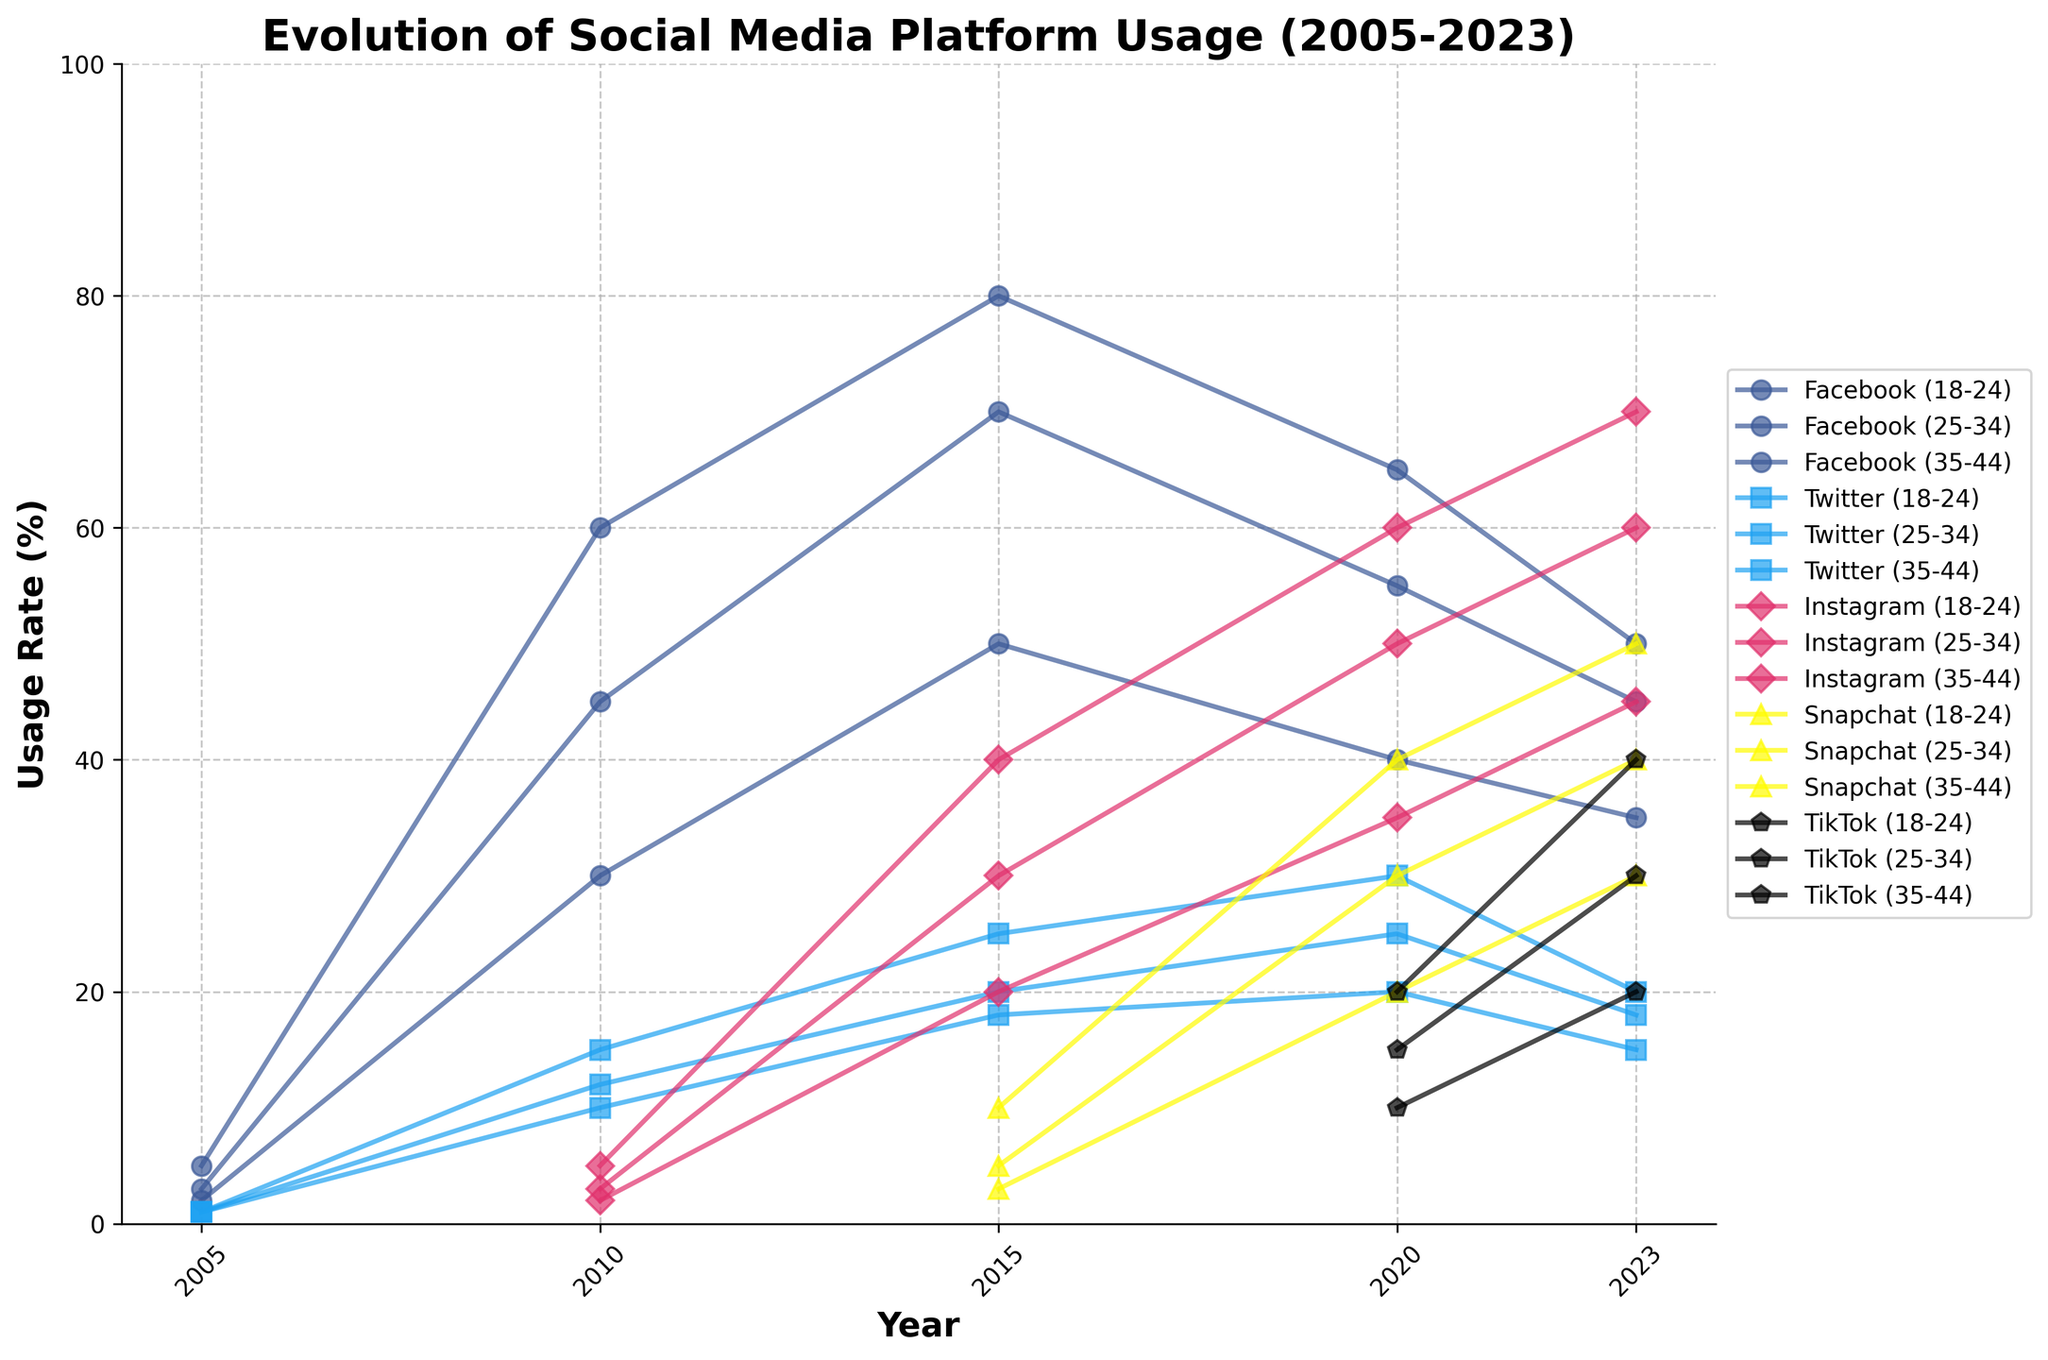What's the title of the figure? The title of the figure is given at the top of the plot.
Answer: Evolution of Social Media Platform Usage (2005-2023) What is the usage rate of Facebook for the 18-24 age group in 2015? Locate the 18-24 age group data points for the year 2015 on the plot, and look at the value on the y-axis for Facebook.
Answer: 80% Which social media platform had the highest usage rate among the 18-24 age group in 2023? Look at all the data points for the 18-24 age group in 2023 and identify the highest point among all platforms.
Answer: Instagram Compare the usage rate of TikTok for the 18-24 age group and the 35-44 age group in 2023. Locate the data points for TikTok in 2023 on the plot for both the 18-24 and 35-44 age groups and compare their values.
Answer: 40% (18-24) and 20% (35-44) How did the usage rate of Snapchat change for the 25-34 age group from 2015 to 2023? Find the Snapchat data points for the 25-34 age group in both 2015 and 2023 and calculate the difference.
Answer: Increased from 5% to 40% What was the difference in Instagram usage rate between the 18-24 and 25-34 age groups in 2020? Locate the Instagram data points for both age groups (18-24 and 25-34) in 2020 and subtract the 25-34 value from the 18-24 value.
Answer: 10% Which age group had the least usage of social media platforms in 2005? Compare the usage rates for all platforms in 2005 among the different age groups and find the one with the lowest values.
Answer: 35-44 What trend do you observe for Twitter usage across all age groups from 2005 to 2023? Examine the Twitter data points for all age groups from 2005 to 2023 and identify any patterns or trends.
Answer: Generally stable or slightly decreasing How does the total usage rate of all platforms for the 25-34 age group in 2023 compare to the 18-24 age group in 2005? Sum the usage rates of all platforms for the 25-34 age group in 2023 and for the 18-24 age group in 2005, then compare the totals.
Answer: 173% (2023) compared to 6% (2005) What was the growth rate of Instagram usage for the 18-24 age group between 2015 and 2020? Determine the Instagram usage rate for the 18-24 age group in both 2015 and 2020, then calculate the percentage increase.
Answer: 50% increase 